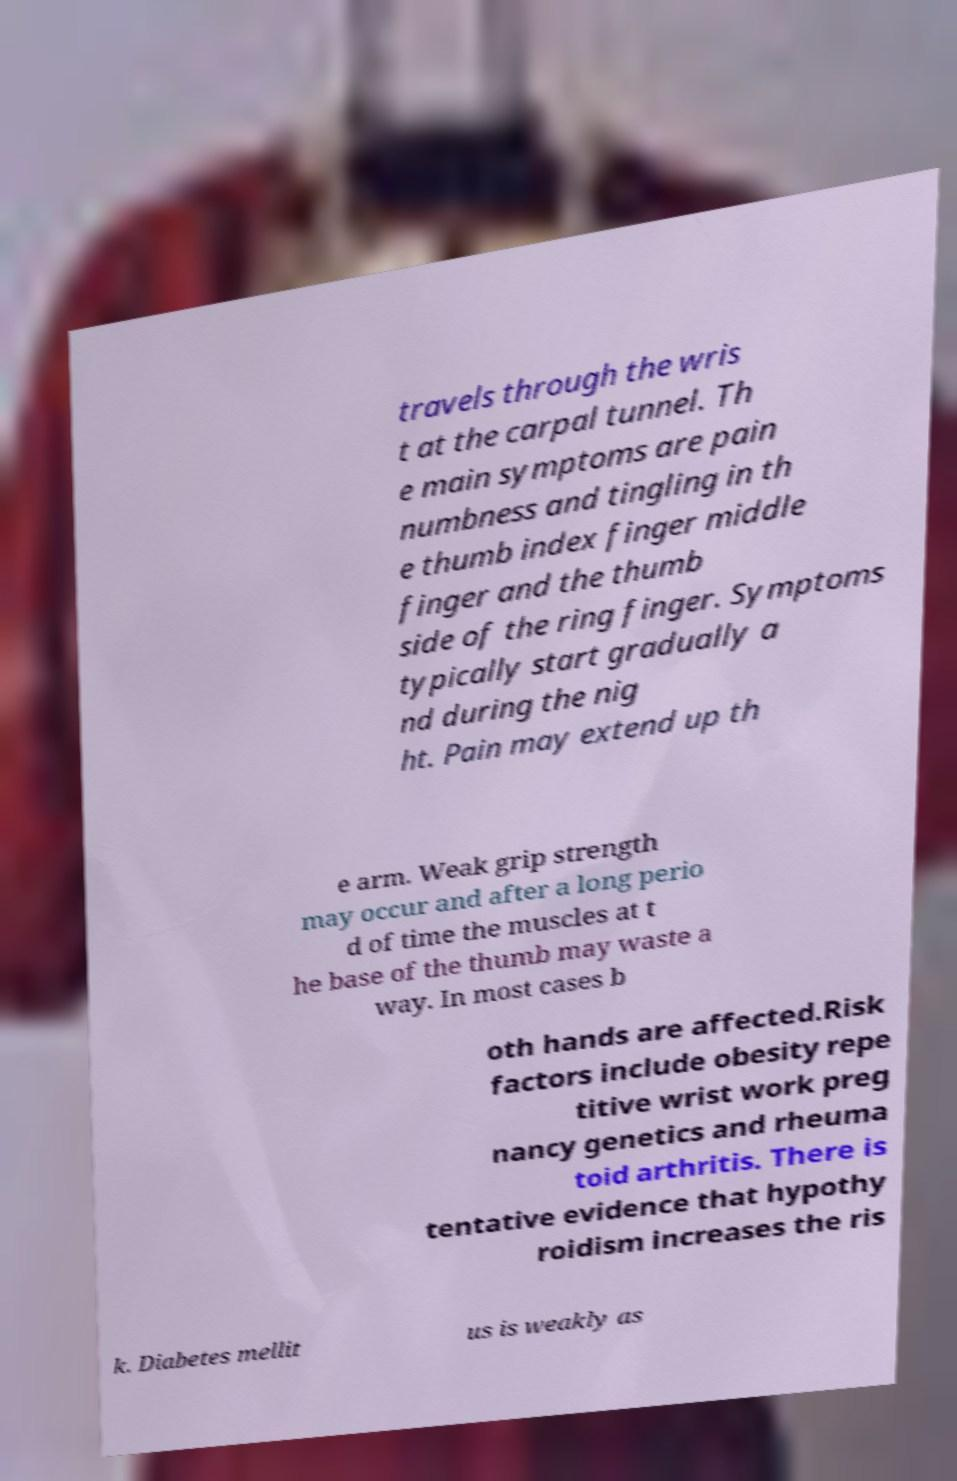Please identify and transcribe the text found in this image. travels through the wris t at the carpal tunnel. Th e main symptoms are pain numbness and tingling in th e thumb index finger middle finger and the thumb side of the ring finger. Symptoms typically start gradually a nd during the nig ht. Pain may extend up th e arm. Weak grip strength may occur and after a long perio d of time the muscles at t he base of the thumb may waste a way. In most cases b oth hands are affected.Risk factors include obesity repe titive wrist work preg nancy genetics and rheuma toid arthritis. There is tentative evidence that hypothy roidism increases the ris k. Diabetes mellit us is weakly as 